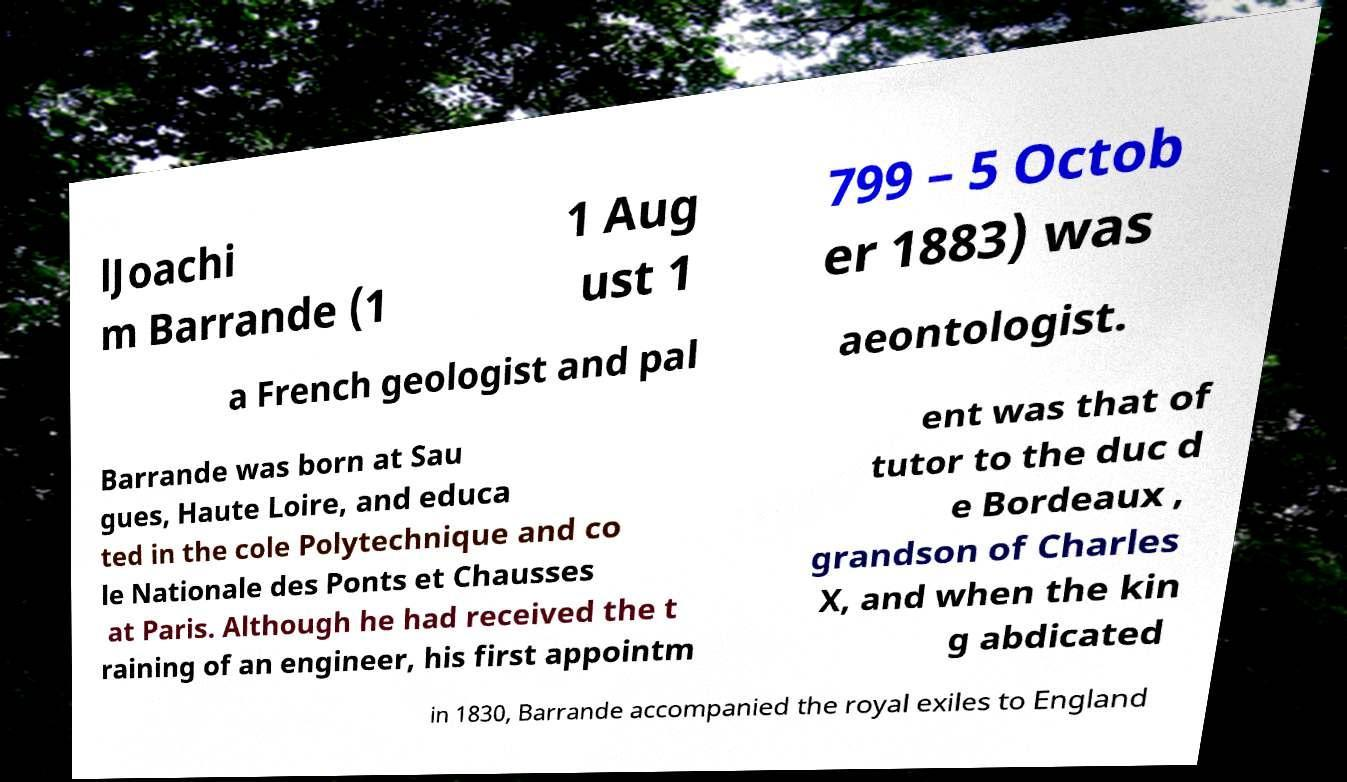Please identify and transcribe the text found in this image. lJoachi m Barrande (1 1 Aug ust 1 799 – 5 Octob er 1883) was a French geologist and pal aeontologist. Barrande was born at Sau gues, Haute Loire, and educa ted in the cole Polytechnique and co le Nationale des Ponts et Chausses at Paris. Although he had received the t raining of an engineer, his first appointm ent was that of tutor to the duc d e Bordeaux , grandson of Charles X, and when the kin g abdicated in 1830, Barrande accompanied the royal exiles to England 